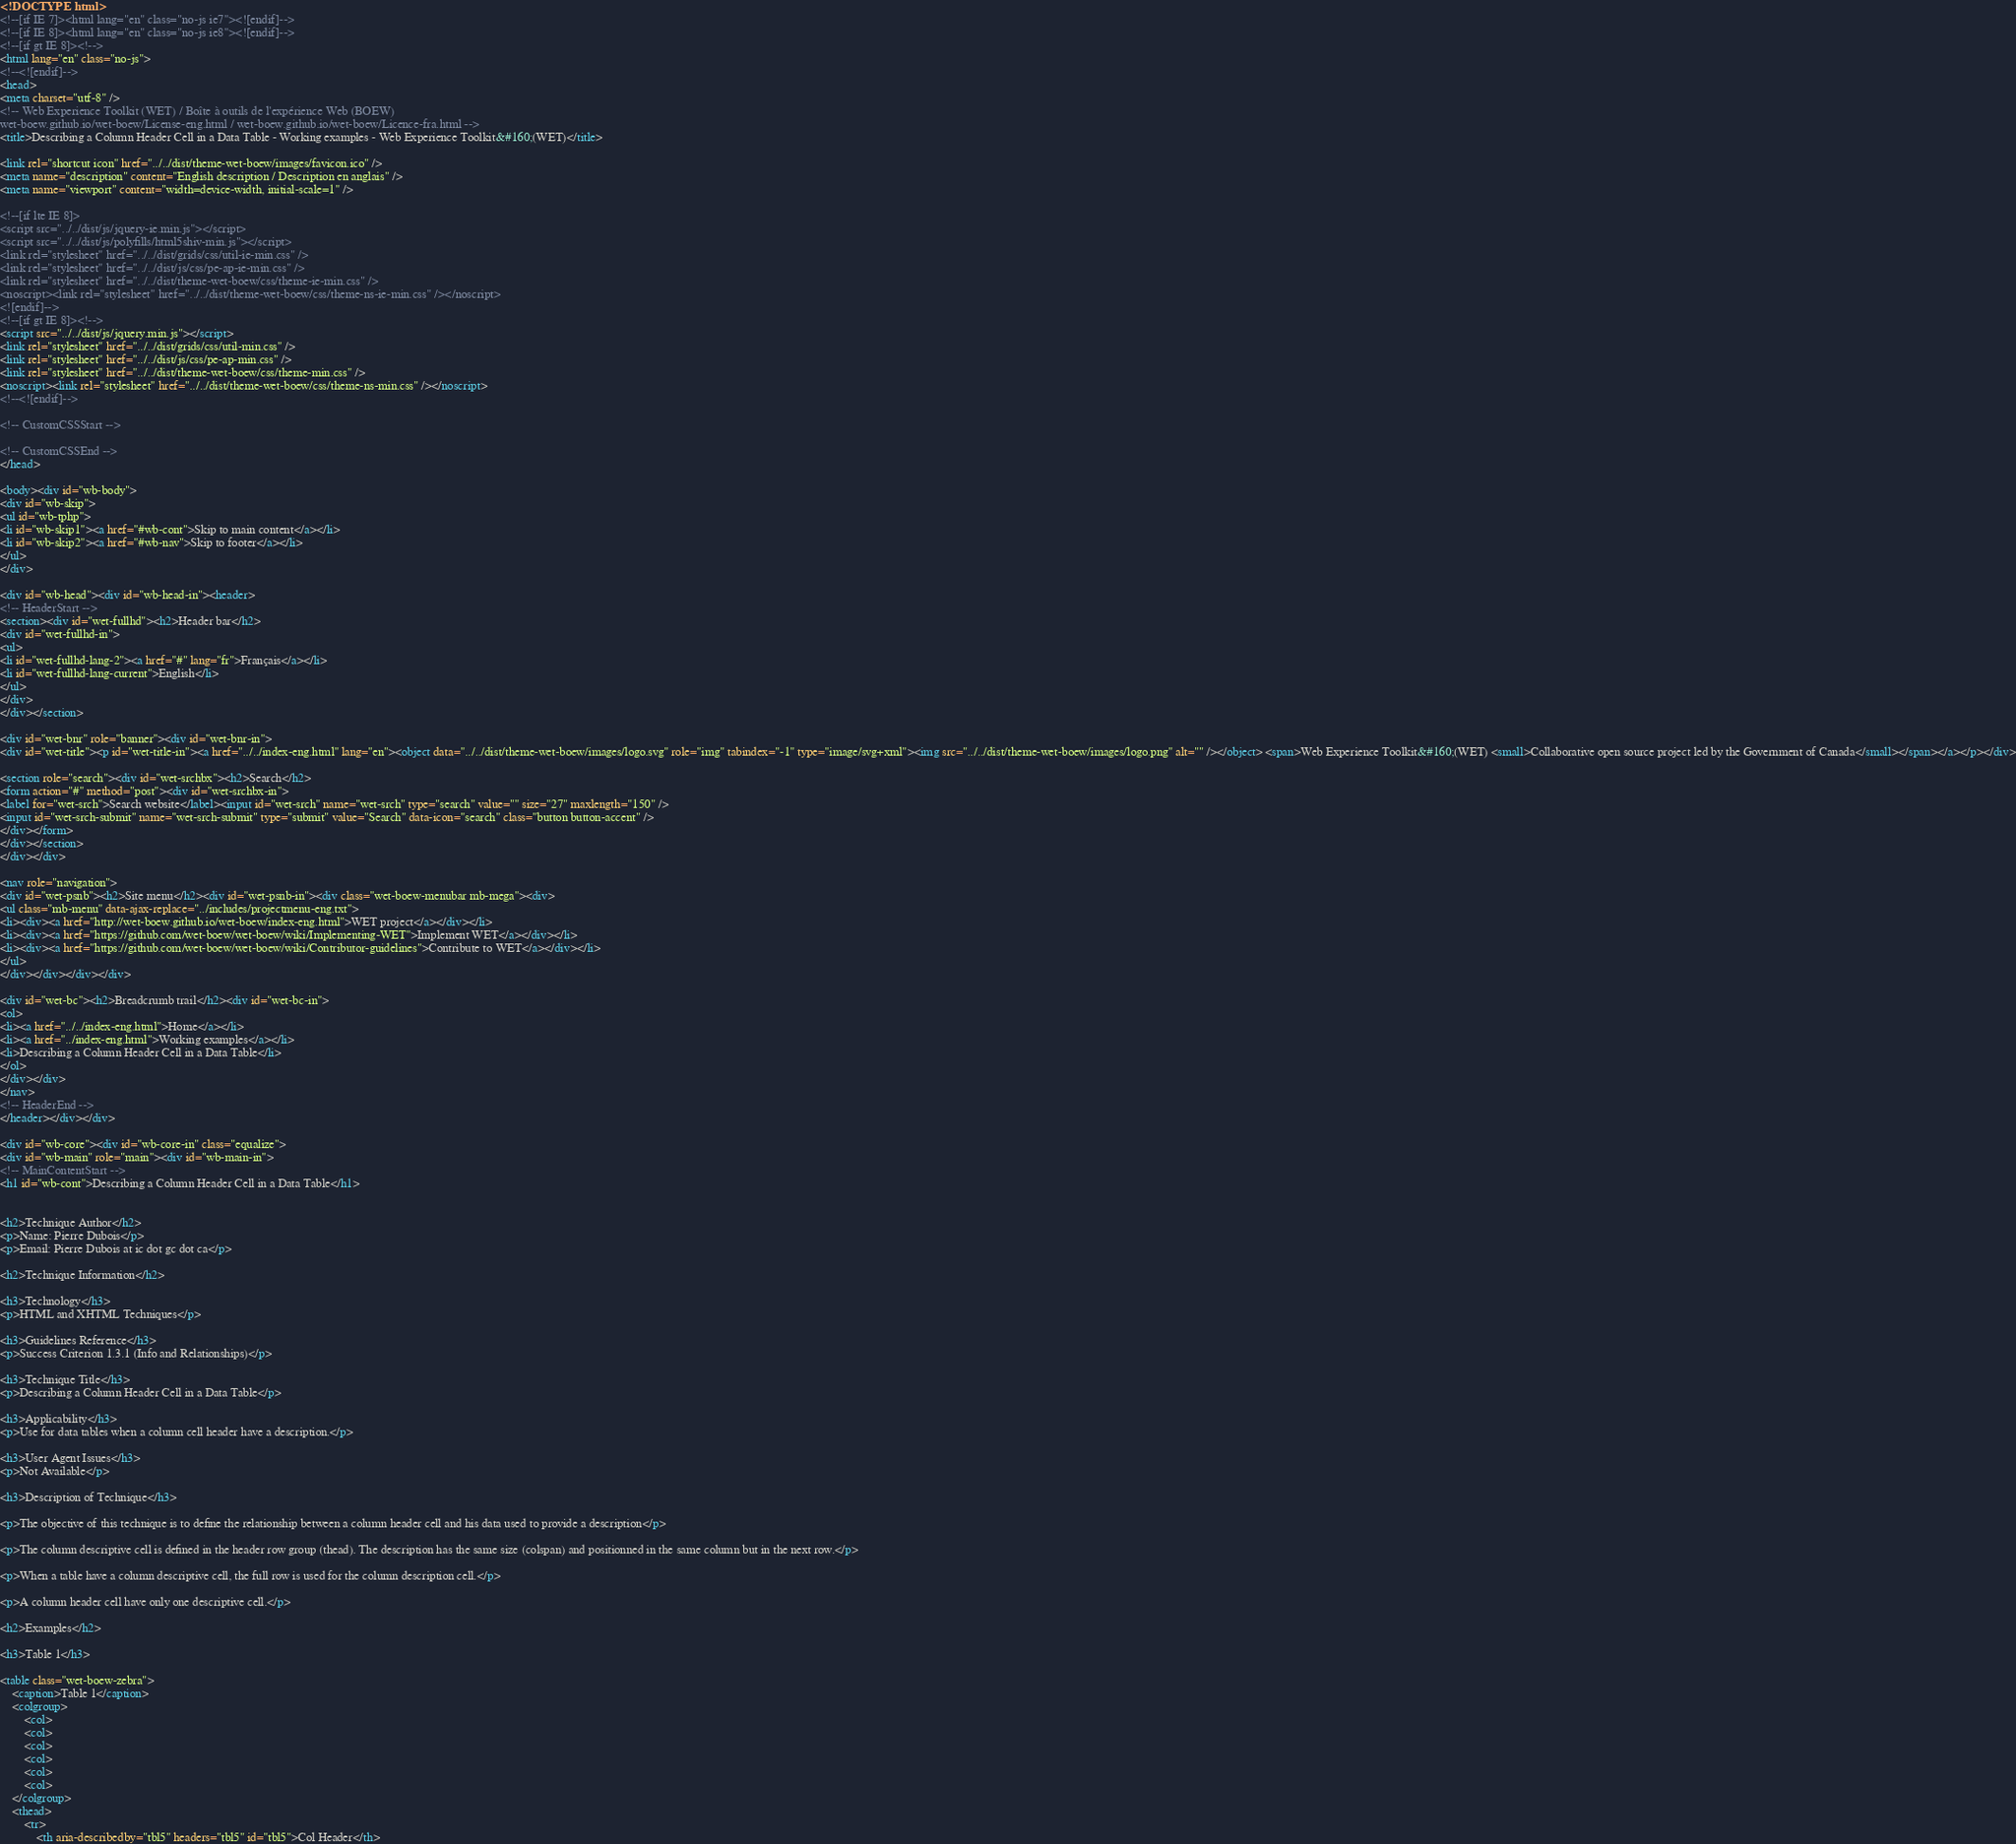<code> <loc_0><loc_0><loc_500><loc_500><_HTML_><!DOCTYPE html>
<!--[if IE 7]><html lang="en" class="no-js ie7"><![endif]-->
<!--[if IE 8]><html lang="en" class="no-js ie8"><![endif]-->
<!--[if gt IE 8]><!-->
<html lang="en" class="no-js">
<!--<![endif]-->
<head>
<meta charset="utf-8" />
<!-- Web Experience Toolkit (WET) / Boîte à outils de l'expérience Web (BOEW)
wet-boew.github.io/wet-boew/License-eng.html / wet-boew.github.io/wet-boew/Licence-fra.html -->
<title>Describing a Column Header Cell in a Data Table - Working examples - Web Experience Toolkit&#160;(WET)</title>

<link rel="shortcut icon" href="../../dist/theme-wet-boew/images/favicon.ico" />
<meta name="description" content="English description / Description en anglais" />
<meta name="viewport" content="width=device-width, initial-scale=1" />

<!--[if lte IE 8]>
<script src="../../dist/js/jquery-ie.min.js"></script>
<script src="../../dist/js/polyfills/html5shiv-min.js"></script>
<link rel="stylesheet" href="../../dist/grids/css/util-ie-min.css" />
<link rel="stylesheet" href="../../dist/js/css/pe-ap-ie-min.css" />
<link rel="stylesheet" href="../../dist/theme-wet-boew/css/theme-ie-min.css" />
<noscript><link rel="stylesheet" href="../../dist/theme-wet-boew/css/theme-ns-ie-min.css" /></noscript>
<![endif]-->
<!--[if gt IE 8]><!-->
<script src="../../dist/js/jquery.min.js"></script>
<link rel="stylesheet" href="../../dist/grids/css/util-min.css" />
<link rel="stylesheet" href="../../dist/js/css/pe-ap-min.css" />
<link rel="stylesheet" href="../../dist/theme-wet-boew/css/theme-min.css" />
<noscript><link rel="stylesheet" href="../../dist/theme-wet-boew/css/theme-ns-min.css" /></noscript>
<!--<![endif]-->

<!-- CustomCSSStart -->

<!-- CustomCSSEnd -->
</head>

<body><div id="wb-body">
<div id="wb-skip">
<ul id="wb-tphp">
<li id="wb-skip1"><a href="#wb-cont">Skip to main content</a></li>
<li id="wb-skip2"><a href="#wb-nav">Skip to footer</a></li>
</ul>
</div>

<div id="wb-head"><div id="wb-head-in"><header>
<!-- HeaderStart -->
<section><div id="wet-fullhd"><h2>Header bar</h2>
<div id="wet-fullhd-in">
<ul>
<li id="wet-fullhd-lang-2"><a href="#" lang="fr">Français</a></li>
<li id="wet-fullhd-lang-current">English</li>
</ul>
</div>
</div></section>

<div id="wet-bnr" role="banner"><div id="wet-bnr-in">
<div id="wet-title"><p id="wet-title-in"><a href="../../index-eng.html" lang="en"><object data="../../dist/theme-wet-boew/images/logo.svg" role="img" tabindex="-1" type="image/svg+xml"><img src="../../dist/theme-wet-boew/images/logo.png" alt="" /></object> <span>Web Experience Toolkit&#160;(WET) <small>Collaborative open source project led by the Government of Canada</small></span></a></p></div>

<section role="search"><div id="wet-srchbx"><h2>Search</h2>
<form action="#" method="post"><div id="wet-srchbx-in">
<label for="wet-srch">Search website</label><input id="wet-srch" name="wet-srch" type="search" value="" size="27" maxlength="150" />
<input id="wet-srch-submit" name="wet-srch-submit" type="submit" value="Search" data-icon="search" class="button button-accent" />
</div></form>
</div></section>
</div></div>

<nav role="navigation">
<div id="wet-psnb"><h2>Site menu</h2><div id="wet-psnb-in"><div class="wet-boew-menubar mb-mega"><div>
<ul class="mb-menu" data-ajax-replace="../includes/projectmenu-eng.txt">
<li><div><a href="http://wet-boew.github.io/wet-boew/index-eng.html">WET project</a></div></li>
<li><div><a href="https://github.com/wet-boew/wet-boew/wiki/Implementing-WET">Implement WET</a></div></li>
<li><div><a href="https://github.com/wet-boew/wet-boew/wiki/Contributor-guidelines">Contribute to WET</a></div></li>
</ul>
</div></div></div></div>

<div id="wet-bc"><h2>Breadcrumb trail</h2><div id="wet-bc-in">
<ol>
<li><a href="../../index-eng.html">Home</a></li>
<li><a href="../index-eng.html">Working examples</a></li>
<li>Describing a Column Header Cell in a Data Table</li>
</ol>
</div></div>
</nav>
<!-- HeaderEnd -->
</header></div></div>

<div id="wb-core"><div id="wb-core-in" class="equalize">
<div id="wb-main" role="main"><div id="wb-main-in">
<!-- MainContentStart -->
<h1 id="wb-cont">Describing a Column Header Cell in a Data Table</h1>


<h2>Technique Author</h2>
<p>Name: Pierre Dubois</p>
<p>Email: Pierre Dubois at ic dot gc dot ca</p>

<h2>Technique Information</h2>

<h3>Technology</h3>
<p>HTML and XHTML Techniques</p>

<h3>Guidelines Reference</h3>
<p>Success Criterion 1.3.1 (Info and Relationships)</p>

<h3>Technique Title</h3>
<p>Describing a Column Header Cell in a Data Table</p>

<h3>Applicability</h3>
<p>Use for data tables when a column cell header have a description.</p>

<h3>User Agent Issues</h3>
<p>Not Available</p>

<h3>Description of Technique</h3>

<p>The objective of this technique is to define the relationship between a column header cell and his data used to provide a description</p>

<p>The column descriptive cell is defined in the header row group (thead). The description has the same size (colspan) and positionned in the same column but in the next row.</p>

<p>When a table have a column descriptive cell, the full row is used for the column description cell.</p>

<p>A column header cell have only one descriptive cell.</p>

<h2>Examples</h2>

<h3>Table 1</h3>

<table class="wet-boew-zebra">
	<caption>Table 1</caption>
	<colgroup>
		<col>
		<col>
		<col>
		<col>
		<col>
		<col>
	</colgroup>
	<thead>
		<tr>
			<th aria-describedby="tbl5" headers="tbl5" id="tbl5">Col Header</th></code> 